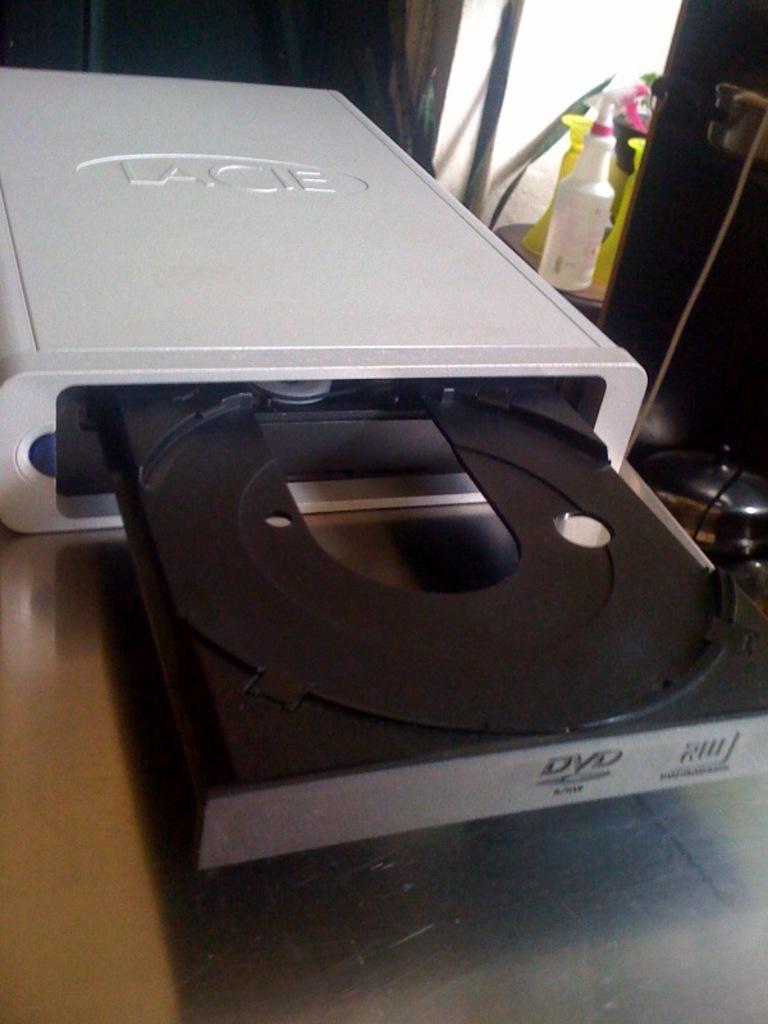What disc format does the drive take?
Keep it short and to the point. Dvd. What brand of drive is shown?
Keep it short and to the point. Lacie. 